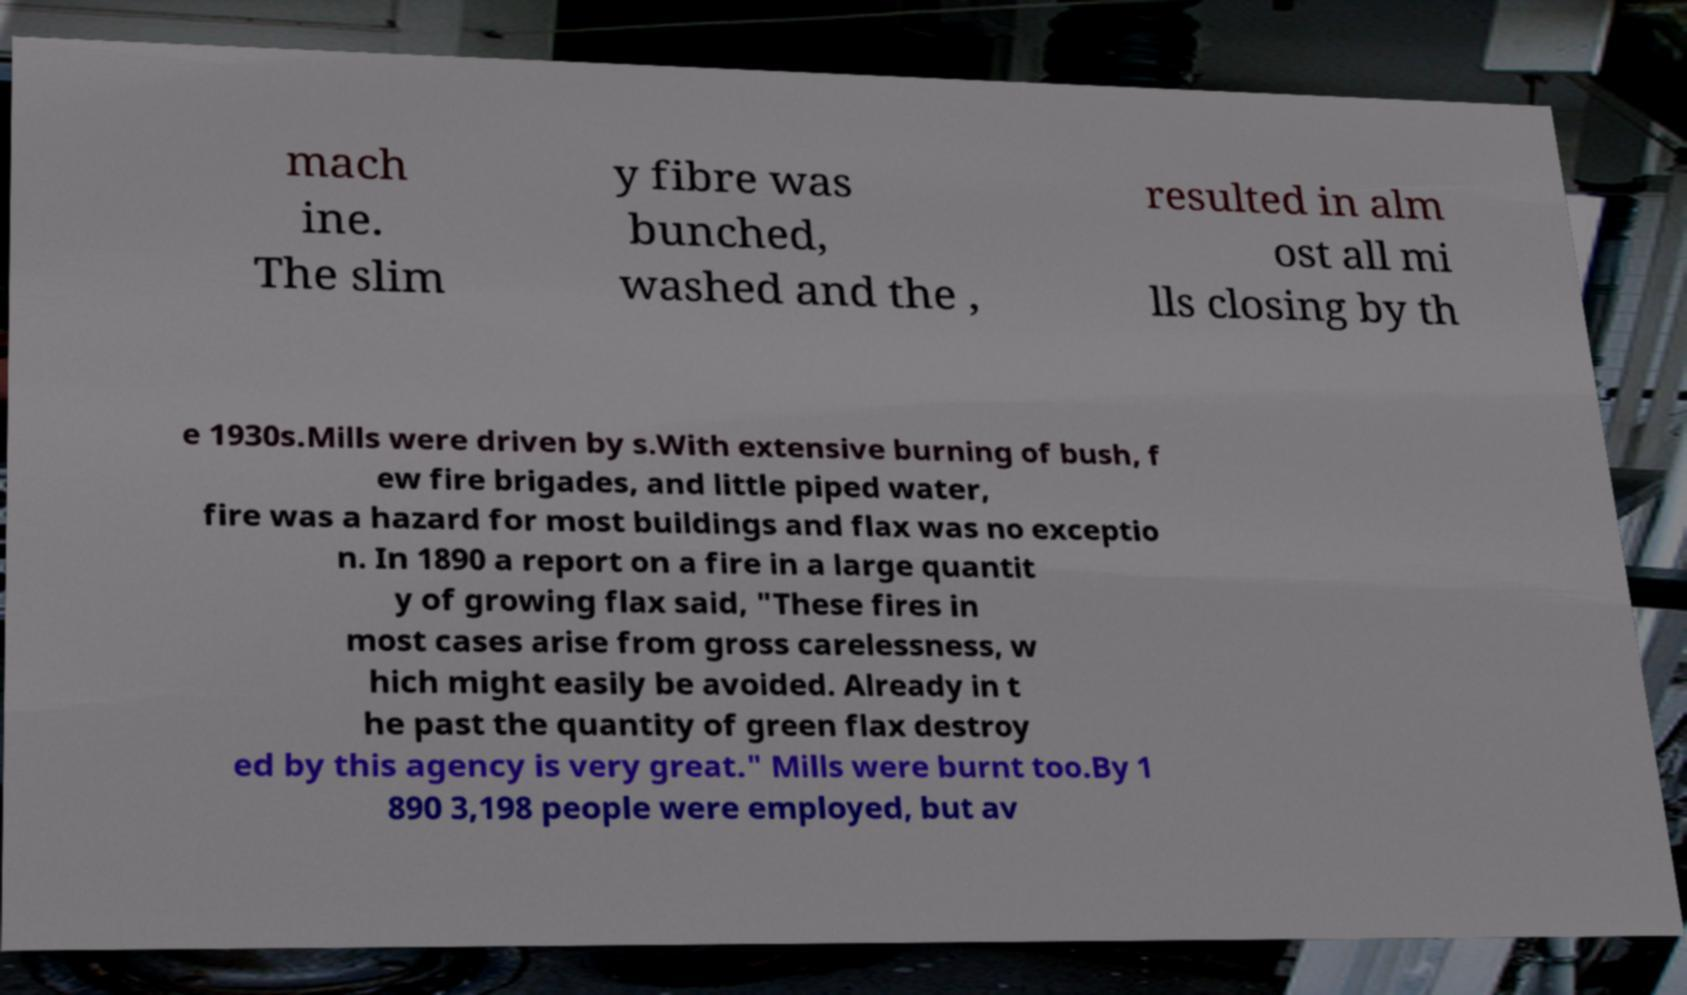Can you accurately transcribe the text from the provided image for me? mach ine. The slim y fibre was bunched, washed and the , resulted in alm ost all mi lls closing by th e 1930s.Mills were driven by s.With extensive burning of bush, f ew fire brigades, and little piped water, fire was a hazard for most buildings and flax was no exceptio n. In 1890 a report on a fire in a large quantit y of growing flax said, "These fires in most cases arise from gross carelessness, w hich might easily be avoided. Already in t he past the quantity of green flax destroy ed by this agency is very great." Mills were burnt too.By 1 890 3,198 people were employed, but av 